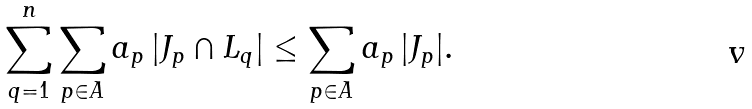Convert formula to latex. <formula><loc_0><loc_0><loc_500><loc_500>\sum _ { q = 1 } ^ { n } \sum _ { p \in A } a _ { p } \, | J _ { p } \cap L _ { q } | \leq \sum _ { p \in A } a _ { p } \, | J _ { p } | .</formula> 